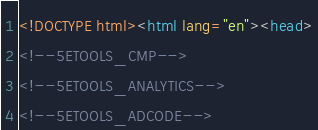Convert code to text. <code><loc_0><loc_0><loc_500><loc_500><_HTML_><!DOCTYPE html><html lang="en"><head>
<!--5ETOOLS_CMP-->
<!--5ETOOLS_ANALYTICS-->
<!--5ETOOLS_ADCODE--></code> 